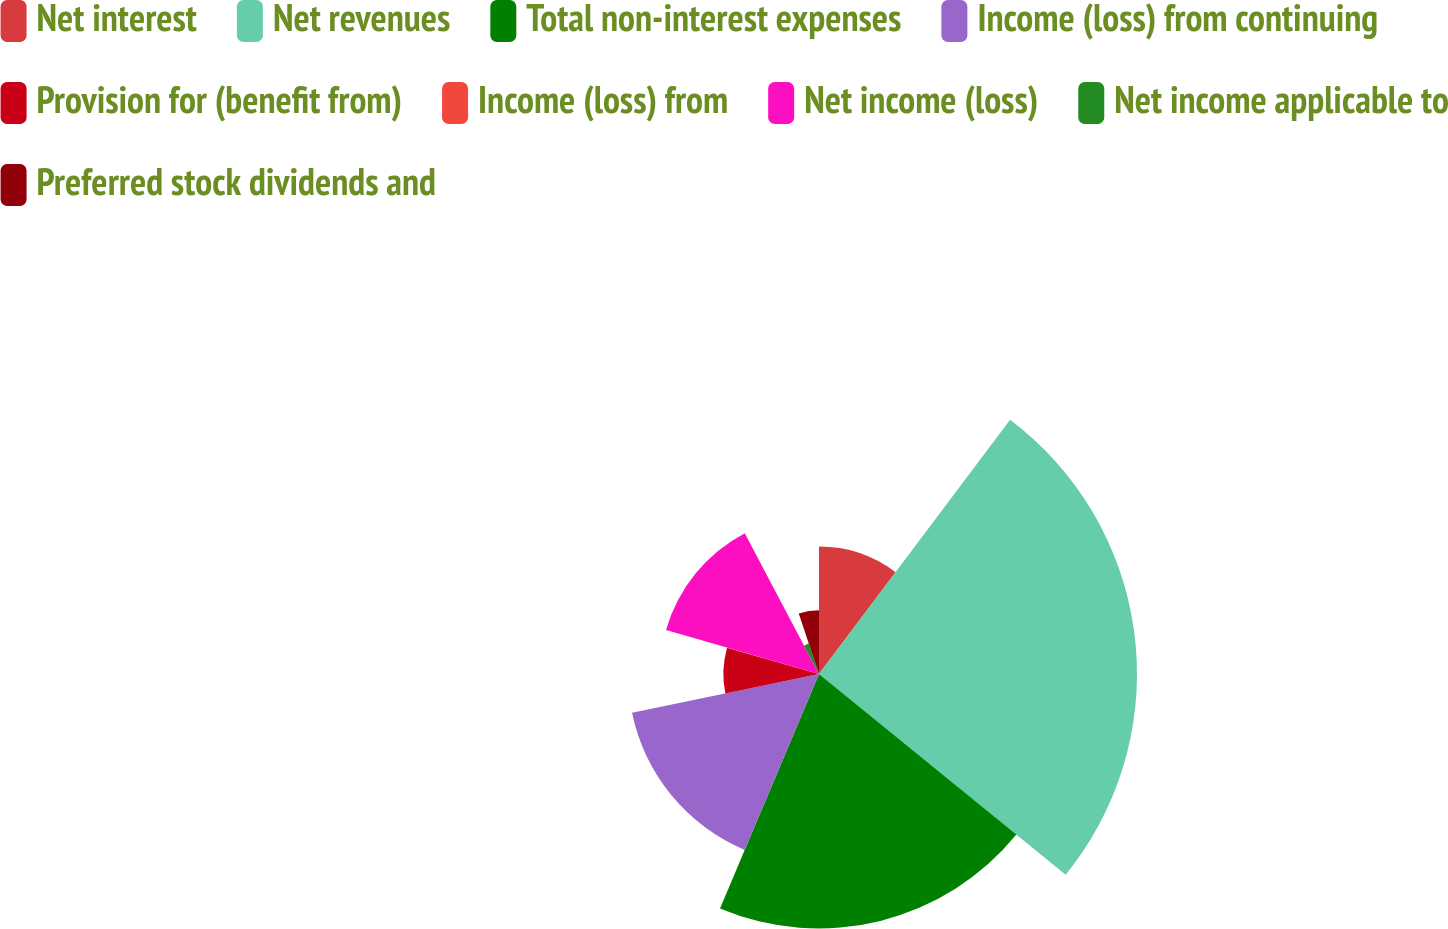Convert chart. <chart><loc_0><loc_0><loc_500><loc_500><pie_chart><fcel>Net interest<fcel>Net revenues<fcel>Total non-interest expenses<fcel>Income (loss) from continuing<fcel>Provision for (benefit from)<fcel>Income (loss) from<fcel>Net income (loss)<fcel>Net income applicable to<fcel>Preferred stock dividends and<nl><fcel>10.26%<fcel>25.61%<fcel>20.49%<fcel>15.38%<fcel>7.7%<fcel>0.02%<fcel>12.82%<fcel>2.58%<fcel>5.14%<nl></chart> 